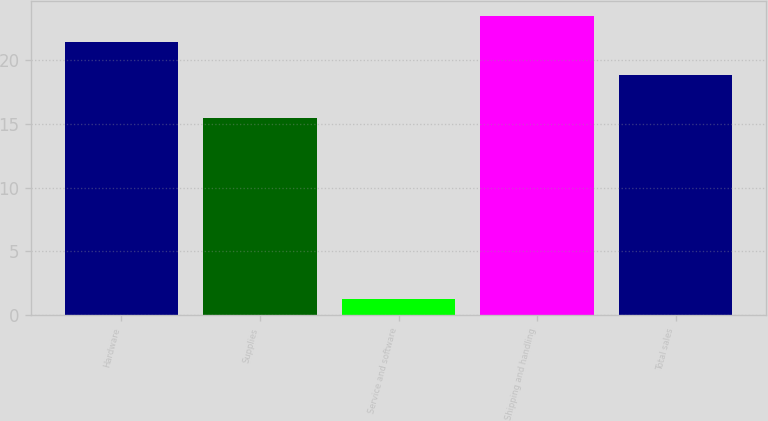<chart> <loc_0><loc_0><loc_500><loc_500><bar_chart><fcel>Hardware<fcel>Supplies<fcel>Service and software<fcel>Shipping and handling<fcel>Total sales<nl><fcel>21.4<fcel>15.5<fcel>1.3<fcel>23.47<fcel>18.8<nl></chart> 